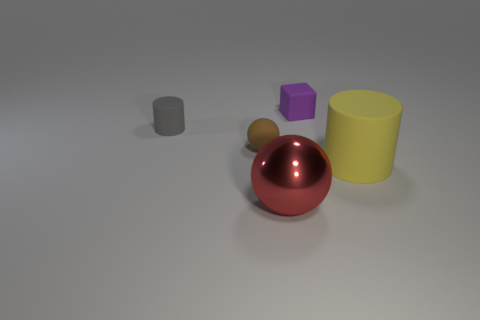Is the size of the rubber cylinder to the right of the purple cube the same as the cylinder behind the yellow rubber thing?
Your answer should be compact. No. How many cylinders are either gray things or large matte things?
Your answer should be very brief. 2. Is the material of the cylinder right of the gray matte cylinder the same as the purple block?
Offer a very short reply. Yes. How many other things are there of the same size as the metallic sphere?
Your answer should be compact. 1. What number of large objects are either gray rubber things or red balls?
Your answer should be compact. 1. Does the small rubber cylinder have the same color as the big matte object?
Your answer should be compact. No. Is the number of objects that are in front of the tiny gray rubber thing greater than the number of purple things that are left of the big matte cylinder?
Your answer should be compact. Yes. Does the thing that is to the left of the brown ball have the same color as the rubber block?
Your answer should be compact. No. Are there any other things of the same color as the big shiny object?
Your response must be concise. No. Is the number of tiny brown balls that are on the right side of the red metal thing greater than the number of large yellow metal cylinders?
Your answer should be compact. No. 